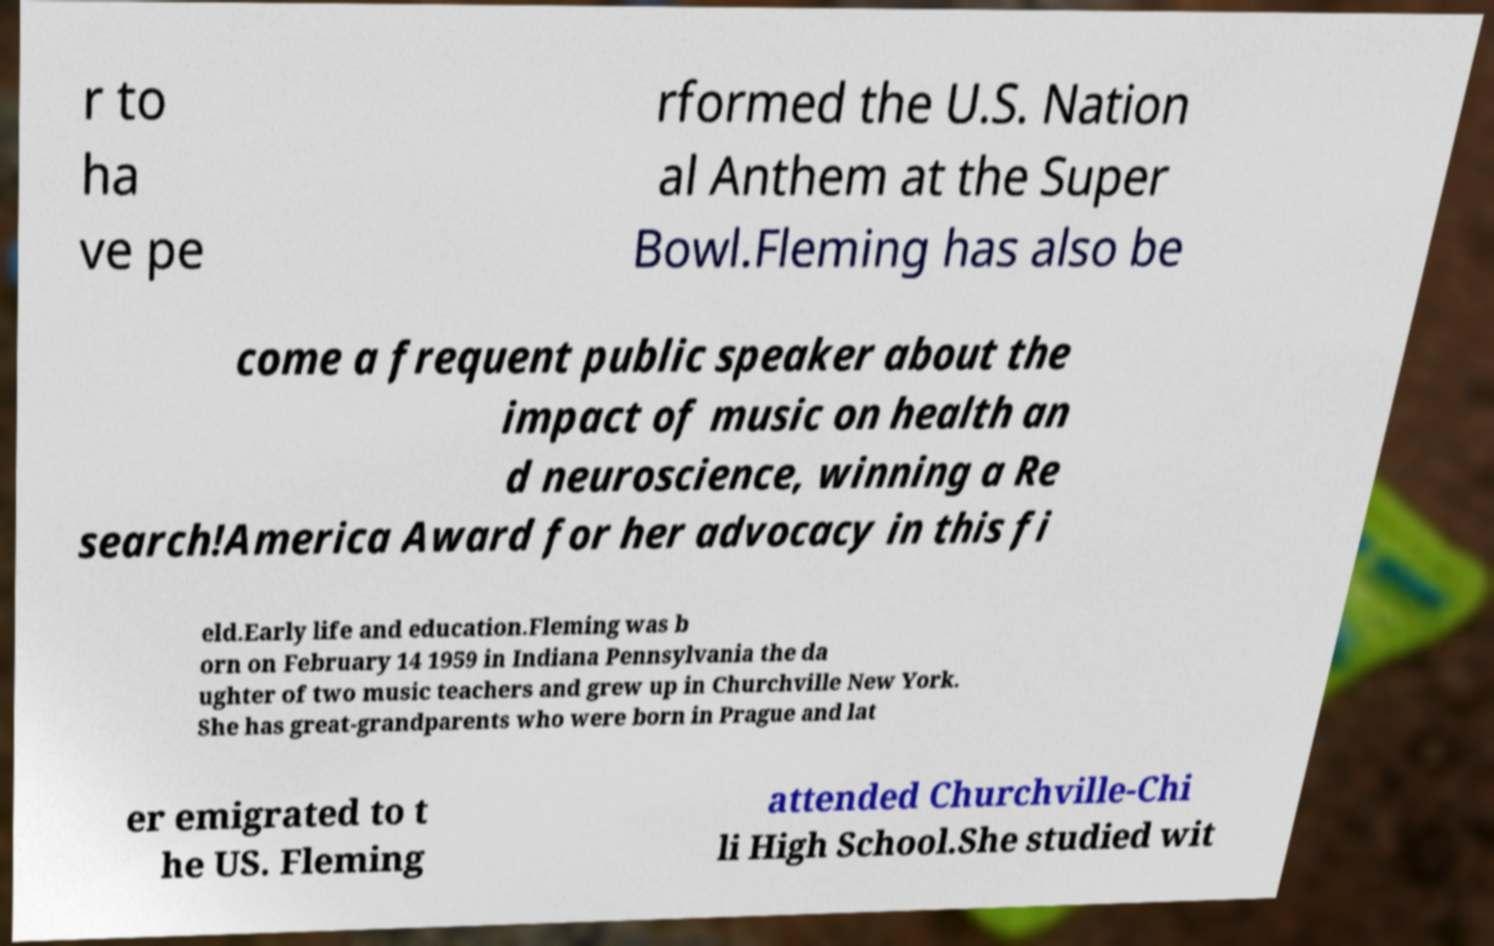Please read and relay the text visible in this image. What does it say? r to ha ve pe rformed the U.S. Nation al Anthem at the Super Bowl.Fleming has also be come a frequent public speaker about the impact of music on health an d neuroscience, winning a Re search!America Award for her advocacy in this fi eld.Early life and education.Fleming was b orn on February 14 1959 in Indiana Pennsylvania the da ughter of two music teachers and grew up in Churchville New York. She has great-grandparents who were born in Prague and lat er emigrated to t he US. Fleming attended Churchville-Chi li High School.She studied wit 